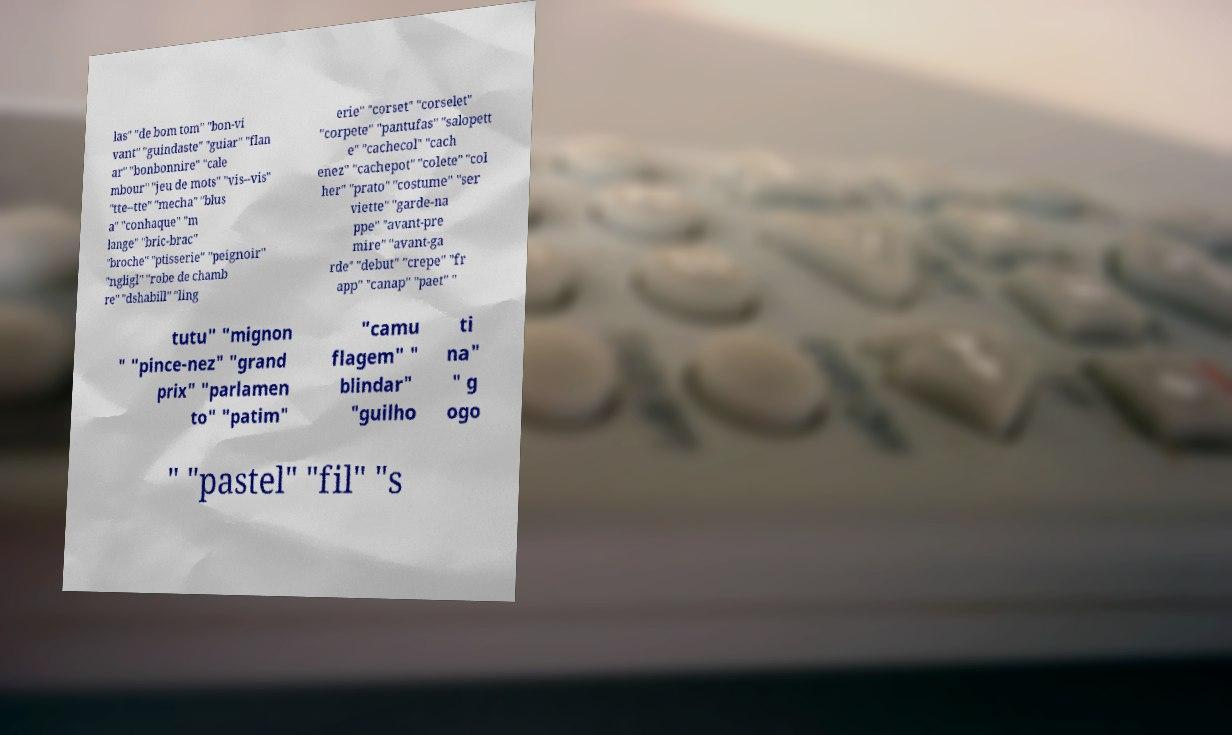Please read and relay the text visible in this image. What does it say? las" "de bom tom" "bon-vi vant" "guindaste" "guiar" "flan ar" "bonbonnire" "cale mbour" "jeu de mots" "vis--vis" "tte--tte" "mecha" "blus a" "conhaque" "m lange" "bric-brac" "broche" "ptisserie" "peignoir" "ngligl" "robe de chamb re" "dshabill" "ling erie" "corset" "corselet" "corpete" "pantufas" "salopett e" "cachecol" "cach enez" "cachepot" "colete" "col her" "prato" "costume" "ser viette" "garde-na ppe" "avant-pre mire" "avant-ga rde" "debut" "crepe" "fr app" "canap" "paet" " tutu" "mignon " "pince-nez" "grand prix" "parlamen to" "patim" "camu flagem" " blindar" "guilho ti na" " g ogo " "pastel" "fil" "s 